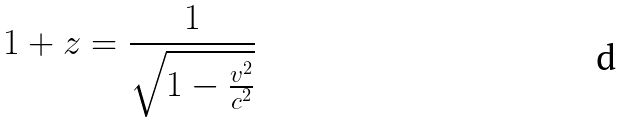Convert formula to latex. <formula><loc_0><loc_0><loc_500><loc_500>1 + z = { \frac { 1 } { \sqrt { 1 - { \frac { v ^ { 2 } } { c ^ { 2 } } } } } }</formula> 